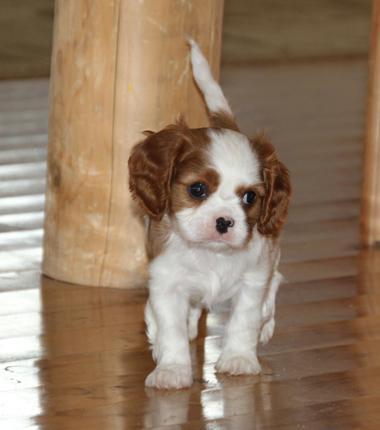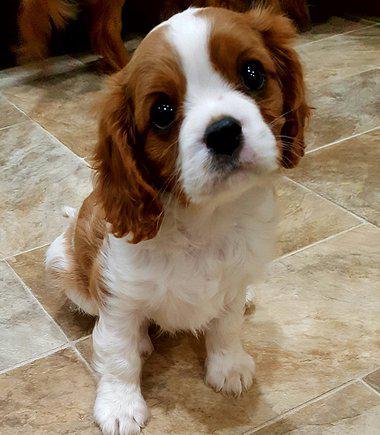The first image is the image on the left, the second image is the image on the right. Examine the images to the left and right. Is the description "Human hands hold at least one puppy in one image." accurate? Answer yes or no. No. The first image is the image on the left, the second image is the image on the right. Assess this claim about the two images: "Someone is holding up at least one of the puppies.". Correct or not? Answer yes or no. No. 